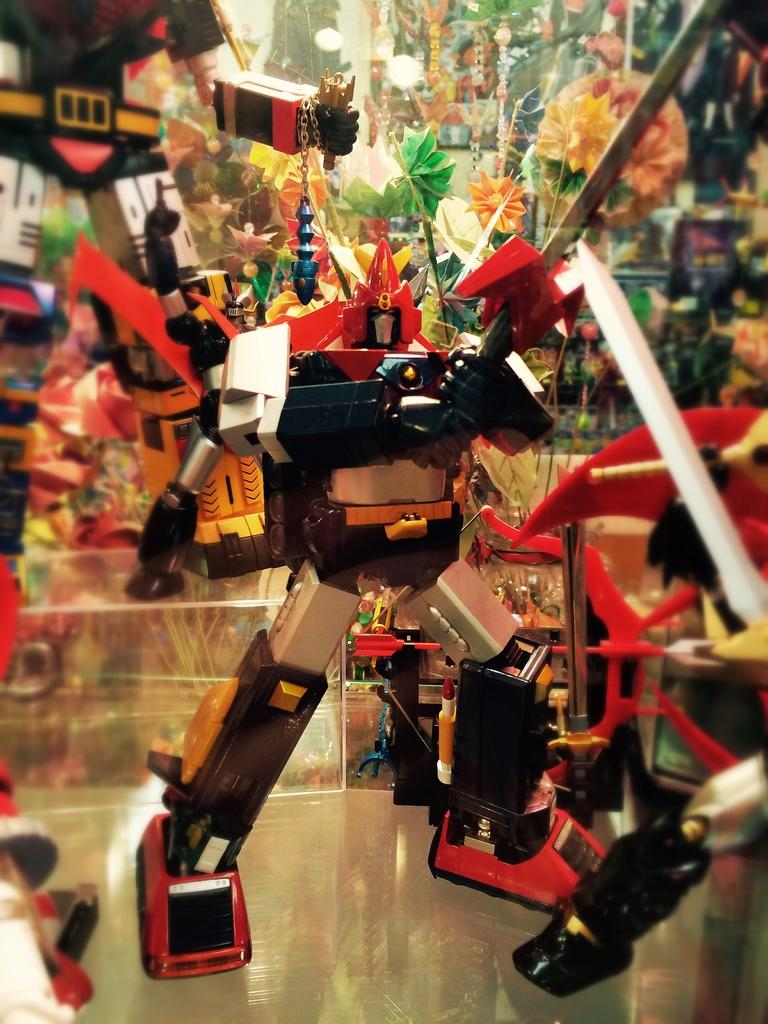What is the main subject of the image? The main subject of the image is a toy robot on a glass. What else can be seen in the image besides the toy robot? There are colorful toys around the glass. What type of coil is used to power the toy robot in the image? There is no information about the type of coil used to power the toy robot in the image. What is the plot of the story being depicted in the image? The image does not depict a story or plot; it is a still image of a toy robot on a glass with colorful toys around it. 